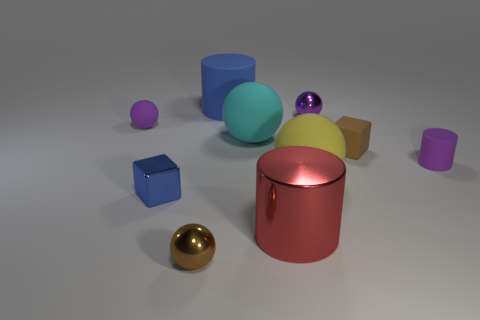Subtract all matte cylinders. How many cylinders are left? 1 Subtract 2 balls. How many balls are left? 3 Subtract all blue cylinders. How many cylinders are left? 2 Subtract all blocks. How many objects are left? 8 Subtract all cyan cylinders. How many red cubes are left? 0 Subtract all large blue things. Subtract all small gray things. How many objects are left? 9 Add 3 small cylinders. How many small cylinders are left? 4 Add 8 yellow spheres. How many yellow spheres exist? 9 Subtract 0 red balls. How many objects are left? 10 Subtract all yellow cylinders. Subtract all brown blocks. How many cylinders are left? 3 